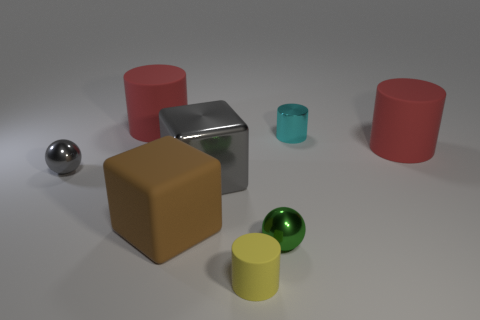Do the metal cylinder and the metallic ball in front of the brown block have the same color?
Keep it short and to the point. No. How many big cylinders are there?
Ensure brevity in your answer.  2. Is there a small object that has the same color as the metal cube?
Offer a terse response. Yes. There is a large cylinder behind the tiny cylinder behind the big cylinder to the right of the tiny green object; what color is it?
Your answer should be very brief. Red. Are the large gray thing and the red object that is on the right side of the brown matte thing made of the same material?
Provide a succinct answer. No. What material is the small cyan thing?
Give a very brief answer. Metal. There is a ball that is the same color as the large metal block; what is its material?
Provide a short and direct response. Metal. How many other objects are the same material as the small yellow cylinder?
Your response must be concise. 3. There is a large rubber object that is in front of the cyan thing and on the left side of the shiny cylinder; what is its shape?
Offer a very short reply. Cube. What color is the big thing that is made of the same material as the green ball?
Offer a very short reply. Gray. 